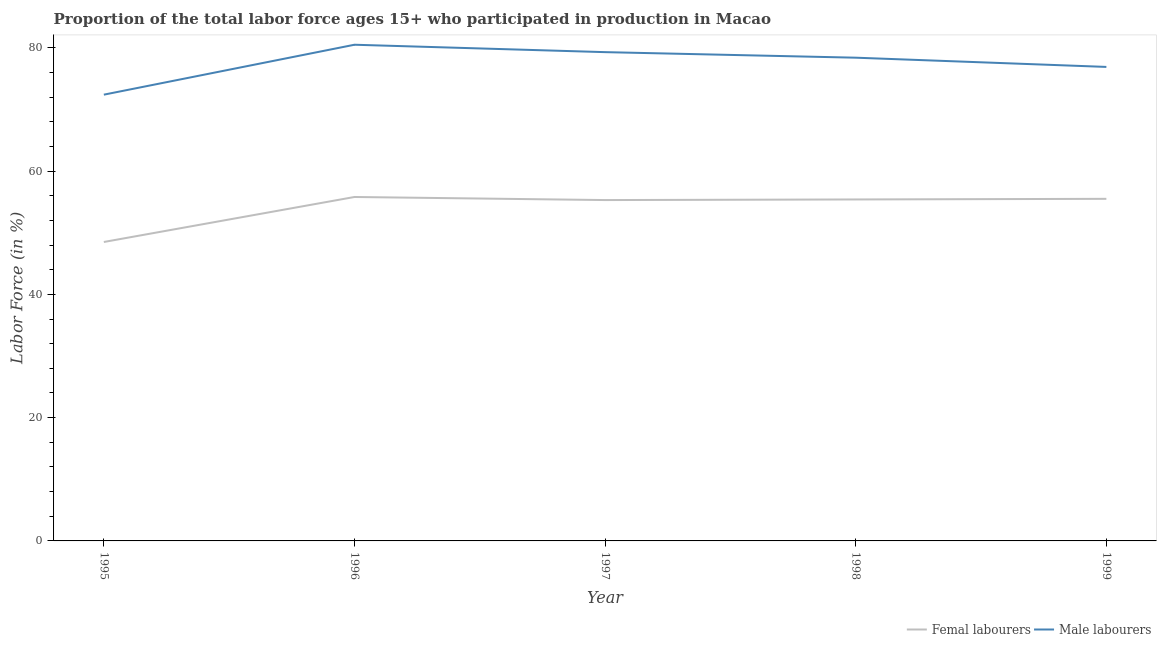How many different coloured lines are there?
Provide a succinct answer. 2. Is the number of lines equal to the number of legend labels?
Offer a very short reply. Yes. What is the percentage of female labor force in 1998?
Your answer should be compact. 55.4. Across all years, what is the maximum percentage of female labor force?
Make the answer very short. 55.8. Across all years, what is the minimum percentage of male labour force?
Provide a short and direct response. 72.4. In which year was the percentage of male labour force maximum?
Offer a terse response. 1996. What is the total percentage of male labour force in the graph?
Keep it short and to the point. 387.5. What is the difference between the percentage of male labour force in 1996 and that in 1999?
Make the answer very short. 3.6. What is the difference between the percentage of male labour force in 1996 and the percentage of female labor force in 1997?
Give a very brief answer. 25.2. What is the average percentage of female labor force per year?
Make the answer very short. 54.1. In the year 1999, what is the difference between the percentage of male labour force and percentage of female labor force?
Make the answer very short. 21.4. What is the ratio of the percentage of male labour force in 1995 to that in 1999?
Your response must be concise. 0.94. Is the percentage of male labour force in 1995 less than that in 1996?
Offer a terse response. Yes. Is the difference between the percentage of male labour force in 1998 and 1999 greater than the difference between the percentage of female labor force in 1998 and 1999?
Provide a succinct answer. Yes. What is the difference between the highest and the second highest percentage of male labour force?
Give a very brief answer. 1.2. What is the difference between the highest and the lowest percentage of male labour force?
Provide a short and direct response. 8.1. In how many years, is the percentage of male labour force greater than the average percentage of male labour force taken over all years?
Give a very brief answer. 3. Is the sum of the percentage of female labor force in 1996 and 1998 greater than the maximum percentage of male labour force across all years?
Your answer should be compact. Yes. Does the percentage of male labour force monotonically increase over the years?
Ensure brevity in your answer.  No. Is the percentage of female labor force strictly greater than the percentage of male labour force over the years?
Provide a short and direct response. No. Is the percentage of female labor force strictly less than the percentage of male labour force over the years?
Keep it short and to the point. Yes. How many lines are there?
Provide a short and direct response. 2. How many years are there in the graph?
Give a very brief answer. 5. Are the values on the major ticks of Y-axis written in scientific E-notation?
Your answer should be very brief. No. Does the graph contain any zero values?
Your answer should be compact. No. How many legend labels are there?
Your answer should be very brief. 2. What is the title of the graph?
Provide a succinct answer. Proportion of the total labor force ages 15+ who participated in production in Macao. Does "Investments" appear as one of the legend labels in the graph?
Give a very brief answer. No. What is the Labor Force (in %) of Femal labourers in 1995?
Keep it short and to the point. 48.5. What is the Labor Force (in %) of Male labourers in 1995?
Offer a very short reply. 72.4. What is the Labor Force (in %) of Femal labourers in 1996?
Your answer should be compact. 55.8. What is the Labor Force (in %) of Male labourers in 1996?
Provide a succinct answer. 80.5. What is the Labor Force (in %) in Femal labourers in 1997?
Your answer should be very brief. 55.3. What is the Labor Force (in %) of Male labourers in 1997?
Provide a succinct answer. 79.3. What is the Labor Force (in %) in Femal labourers in 1998?
Your answer should be very brief. 55.4. What is the Labor Force (in %) in Male labourers in 1998?
Provide a succinct answer. 78.4. What is the Labor Force (in %) in Femal labourers in 1999?
Your answer should be very brief. 55.5. What is the Labor Force (in %) in Male labourers in 1999?
Make the answer very short. 76.9. Across all years, what is the maximum Labor Force (in %) in Femal labourers?
Provide a short and direct response. 55.8. Across all years, what is the maximum Labor Force (in %) of Male labourers?
Keep it short and to the point. 80.5. Across all years, what is the minimum Labor Force (in %) of Femal labourers?
Make the answer very short. 48.5. Across all years, what is the minimum Labor Force (in %) in Male labourers?
Provide a short and direct response. 72.4. What is the total Labor Force (in %) in Femal labourers in the graph?
Provide a short and direct response. 270.5. What is the total Labor Force (in %) of Male labourers in the graph?
Your response must be concise. 387.5. What is the difference between the Labor Force (in %) of Femal labourers in 1995 and that in 1996?
Give a very brief answer. -7.3. What is the difference between the Labor Force (in %) of Femal labourers in 1995 and that in 1997?
Provide a short and direct response. -6.8. What is the difference between the Labor Force (in %) of Femal labourers in 1995 and that in 1998?
Your answer should be compact. -6.9. What is the difference between the Labor Force (in %) in Male labourers in 1995 and that in 1998?
Provide a succinct answer. -6. What is the difference between the Labor Force (in %) in Femal labourers in 1995 and that in 1999?
Offer a very short reply. -7. What is the difference between the Labor Force (in %) of Male labourers in 1995 and that in 1999?
Offer a terse response. -4.5. What is the difference between the Labor Force (in %) in Femal labourers in 1996 and that in 1997?
Give a very brief answer. 0.5. What is the difference between the Labor Force (in %) of Male labourers in 1996 and that in 1997?
Offer a terse response. 1.2. What is the difference between the Labor Force (in %) in Femal labourers in 1996 and that in 1998?
Your response must be concise. 0.4. What is the difference between the Labor Force (in %) of Male labourers in 1997 and that in 1998?
Offer a very short reply. 0.9. What is the difference between the Labor Force (in %) of Femal labourers in 1997 and that in 1999?
Give a very brief answer. -0.2. What is the difference between the Labor Force (in %) of Male labourers in 1997 and that in 1999?
Ensure brevity in your answer.  2.4. What is the difference between the Labor Force (in %) of Male labourers in 1998 and that in 1999?
Your answer should be compact. 1.5. What is the difference between the Labor Force (in %) of Femal labourers in 1995 and the Labor Force (in %) of Male labourers in 1996?
Make the answer very short. -32. What is the difference between the Labor Force (in %) in Femal labourers in 1995 and the Labor Force (in %) in Male labourers in 1997?
Your answer should be compact. -30.8. What is the difference between the Labor Force (in %) of Femal labourers in 1995 and the Labor Force (in %) of Male labourers in 1998?
Your answer should be very brief. -29.9. What is the difference between the Labor Force (in %) of Femal labourers in 1995 and the Labor Force (in %) of Male labourers in 1999?
Ensure brevity in your answer.  -28.4. What is the difference between the Labor Force (in %) in Femal labourers in 1996 and the Labor Force (in %) in Male labourers in 1997?
Make the answer very short. -23.5. What is the difference between the Labor Force (in %) in Femal labourers in 1996 and the Labor Force (in %) in Male labourers in 1998?
Offer a very short reply. -22.6. What is the difference between the Labor Force (in %) in Femal labourers in 1996 and the Labor Force (in %) in Male labourers in 1999?
Keep it short and to the point. -21.1. What is the difference between the Labor Force (in %) in Femal labourers in 1997 and the Labor Force (in %) in Male labourers in 1998?
Your answer should be very brief. -23.1. What is the difference between the Labor Force (in %) of Femal labourers in 1997 and the Labor Force (in %) of Male labourers in 1999?
Keep it short and to the point. -21.6. What is the difference between the Labor Force (in %) of Femal labourers in 1998 and the Labor Force (in %) of Male labourers in 1999?
Offer a very short reply. -21.5. What is the average Labor Force (in %) in Femal labourers per year?
Your answer should be compact. 54.1. What is the average Labor Force (in %) in Male labourers per year?
Ensure brevity in your answer.  77.5. In the year 1995, what is the difference between the Labor Force (in %) of Femal labourers and Labor Force (in %) of Male labourers?
Make the answer very short. -23.9. In the year 1996, what is the difference between the Labor Force (in %) in Femal labourers and Labor Force (in %) in Male labourers?
Provide a succinct answer. -24.7. In the year 1997, what is the difference between the Labor Force (in %) of Femal labourers and Labor Force (in %) of Male labourers?
Provide a succinct answer. -24. In the year 1999, what is the difference between the Labor Force (in %) of Femal labourers and Labor Force (in %) of Male labourers?
Give a very brief answer. -21.4. What is the ratio of the Labor Force (in %) in Femal labourers in 1995 to that in 1996?
Offer a very short reply. 0.87. What is the ratio of the Labor Force (in %) in Male labourers in 1995 to that in 1996?
Make the answer very short. 0.9. What is the ratio of the Labor Force (in %) in Femal labourers in 1995 to that in 1997?
Provide a succinct answer. 0.88. What is the ratio of the Labor Force (in %) in Femal labourers in 1995 to that in 1998?
Offer a very short reply. 0.88. What is the ratio of the Labor Force (in %) in Male labourers in 1995 to that in 1998?
Your answer should be very brief. 0.92. What is the ratio of the Labor Force (in %) of Femal labourers in 1995 to that in 1999?
Make the answer very short. 0.87. What is the ratio of the Labor Force (in %) of Male labourers in 1995 to that in 1999?
Give a very brief answer. 0.94. What is the ratio of the Labor Force (in %) in Femal labourers in 1996 to that in 1997?
Provide a short and direct response. 1.01. What is the ratio of the Labor Force (in %) in Male labourers in 1996 to that in 1997?
Make the answer very short. 1.02. What is the ratio of the Labor Force (in %) in Male labourers in 1996 to that in 1998?
Offer a terse response. 1.03. What is the ratio of the Labor Force (in %) in Femal labourers in 1996 to that in 1999?
Keep it short and to the point. 1.01. What is the ratio of the Labor Force (in %) in Male labourers in 1996 to that in 1999?
Your answer should be compact. 1.05. What is the ratio of the Labor Force (in %) of Femal labourers in 1997 to that in 1998?
Offer a very short reply. 1. What is the ratio of the Labor Force (in %) of Male labourers in 1997 to that in 1998?
Make the answer very short. 1.01. What is the ratio of the Labor Force (in %) of Femal labourers in 1997 to that in 1999?
Your answer should be compact. 1. What is the ratio of the Labor Force (in %) of Male labourers in 1997 to that in 1999?
Your answer should be compact. 1.03. What is the ratio of the Labor Force (in %) in Femal labourers in 1998 to that in 1999?
Keep it short and to the point. 1. What is the ratio of the Labor Force (in %) in Male labourers in 1998 to that in 1999?
Offer a very short reply. 1.02. What is the difference between the highest and the second highest Labor Force (in %) in Femal labourers?
Provide a short and direct response. 0.3. What is the difference between the highest and the second highest Labor Force (in %) of Male labourers?
Keep it short and to the point. 1.2. What is the difference between the highest and the lowest Labor Force (in %) in Femal labourers?
Offer a terse response. 7.3. What is the difference between the highest and the lowest Labor Force (in %) of Male labourers?
Provide a succinct answer. 8.1. 